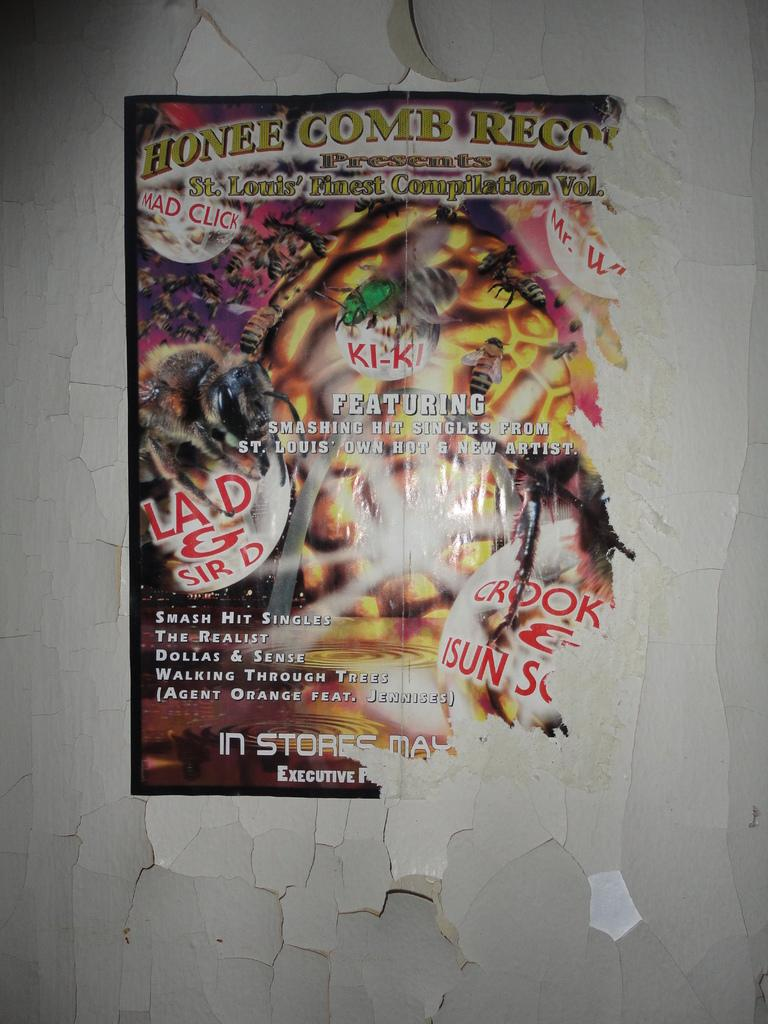<image>
Create a compact narrative representing the image presented. A poster hung on a crumbling wall advertises Honee Comb Records, Featuring smashing singles from St. Louis' Own Hot and New Artist. 